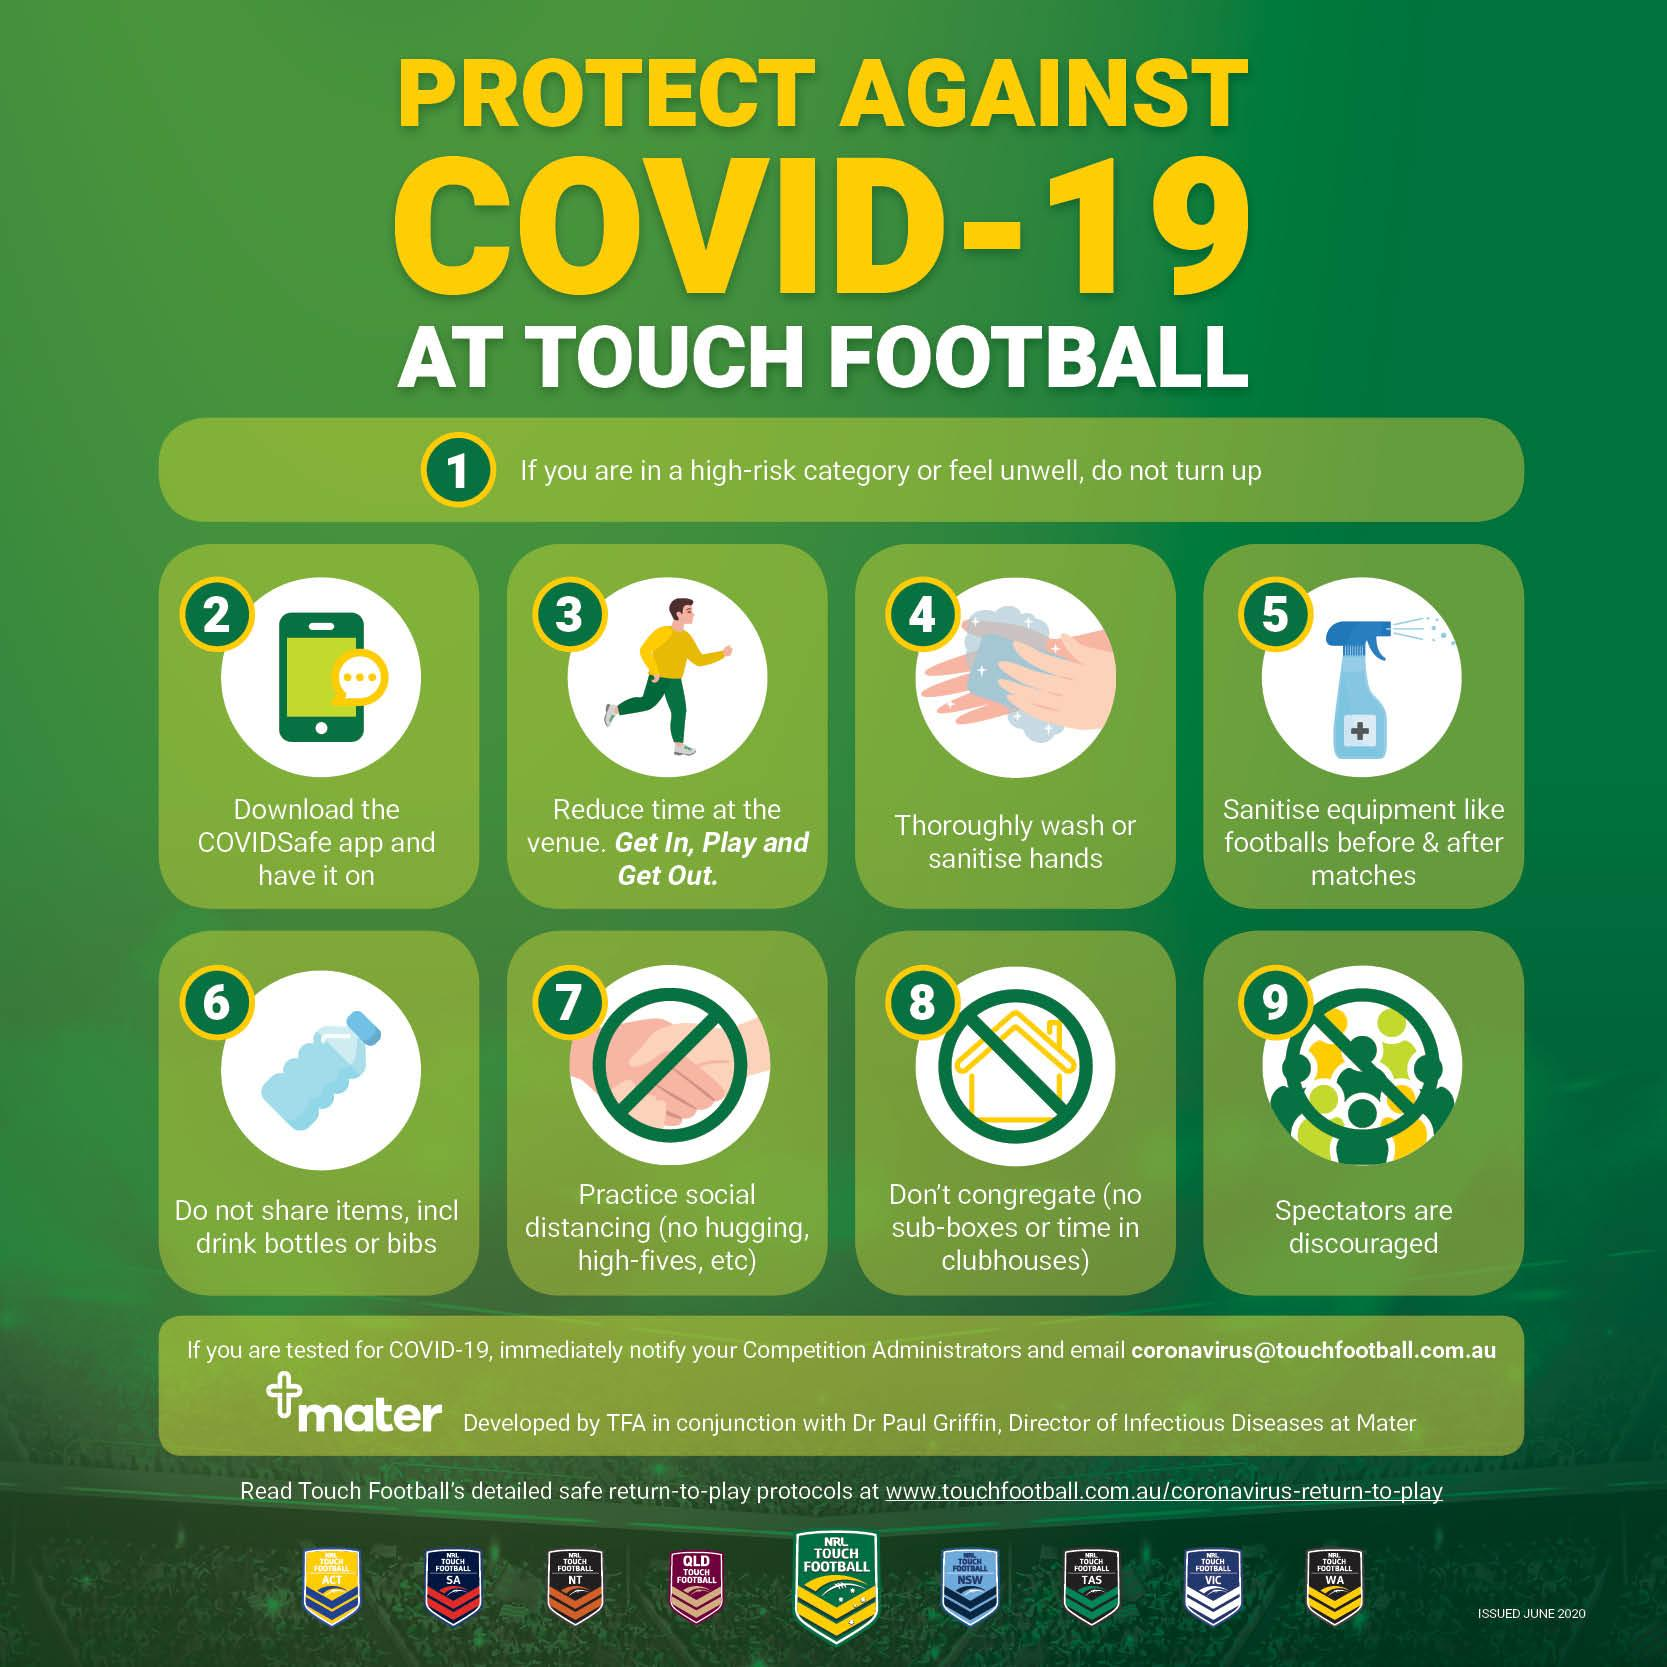Give some essential details in this illustration. This infographic image displays three examples of don'ts. 